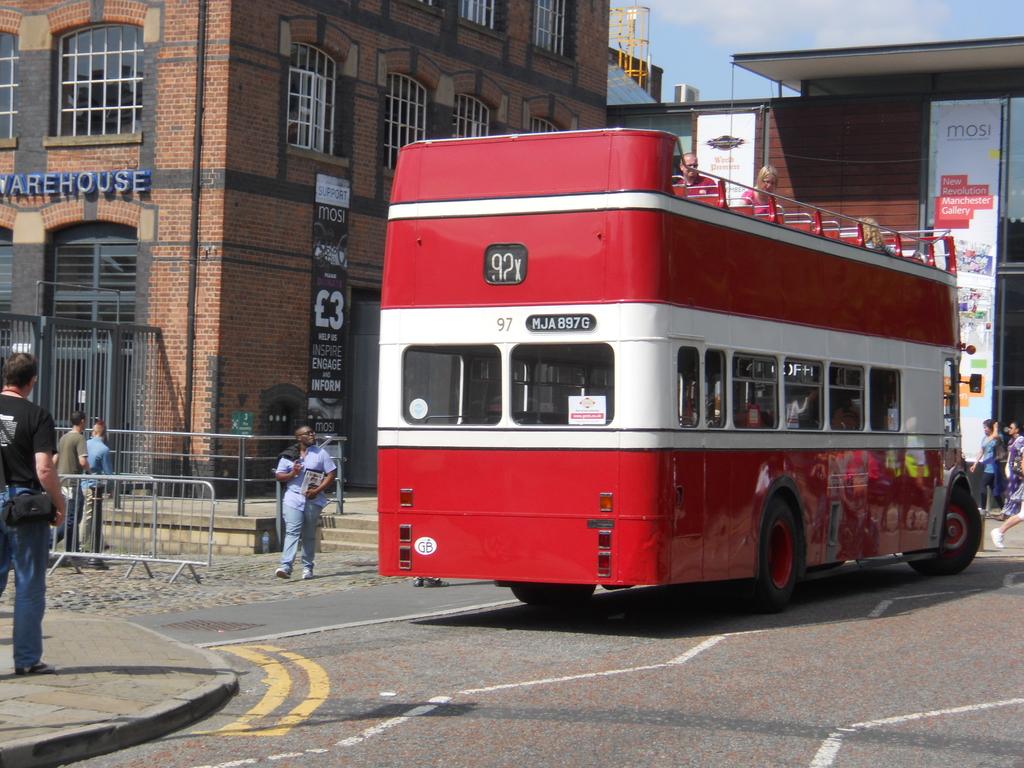What does the building to the left say?
Your answer should be compact. Warehouse. 